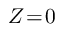<formula> <loc_0><loc_0><loc_500><loc_500>Z \, = \, 0</formula> 